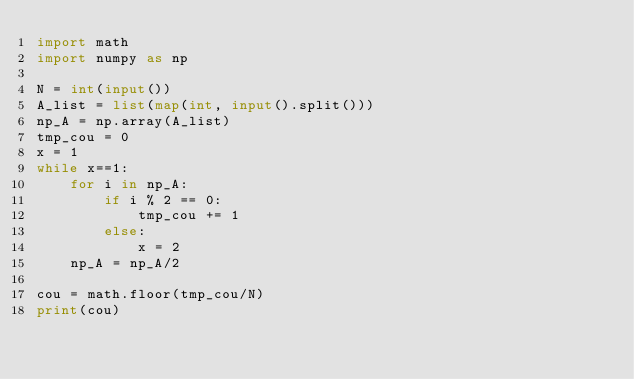<code> <loc_0><loc_0><loc_500><loc_500><_Python_>import math
import numpy as np

N = int(input())
A_list = list(map(int, input().split()))
np_A = np.array(A_list)
tmp_cou = 0
x = 1
while x==1:
    for i in np_A:
        if i % 2 == 0:
            tmp_cou += 1
        else:
            x = 2
    np_A = np_A/2

cou = math.floor(tmp_cou/N)
print(cou)
</code> 